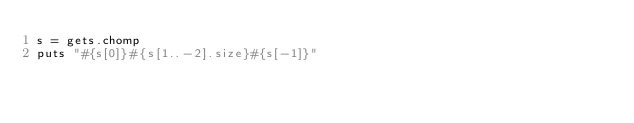<code> <loc_0><loc_0><loc_500><loc_500><_Ruby_>s = gets.chomp
puts "#{s[0]}#{s[1..-2].size}#{s[-1]}"
</code> 